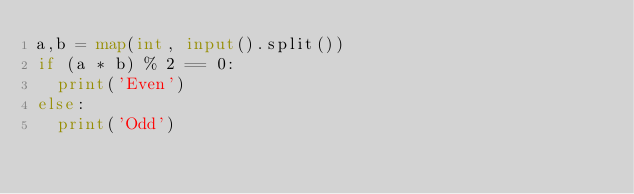<code> <loc_0><loc_0><loc_500><loc_500><_Python_>a,b = map(int, input().split())
if (a * b) % 2 == 0:
  print('Even')
else:
  print('Odd')</code> 